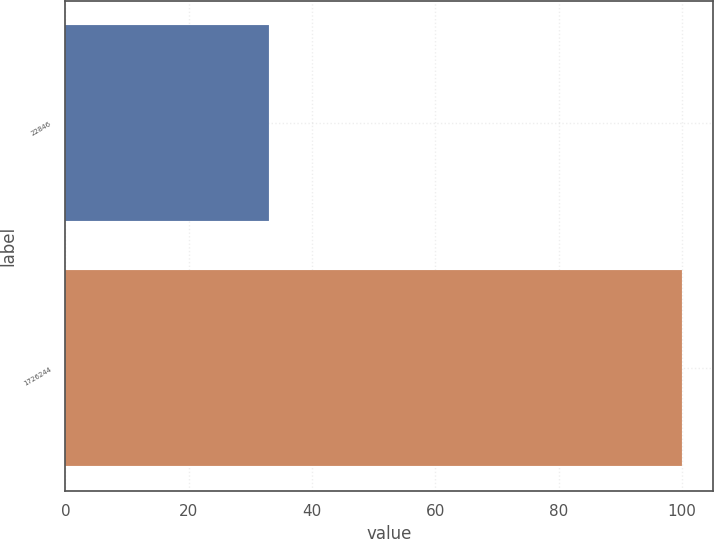<chart> <loc_0><loc_0><loc_500><loc_500><bar_chart><fcel>22846<fcel>1726244<nl><fcel>33<fcel>100<nl></chart> 